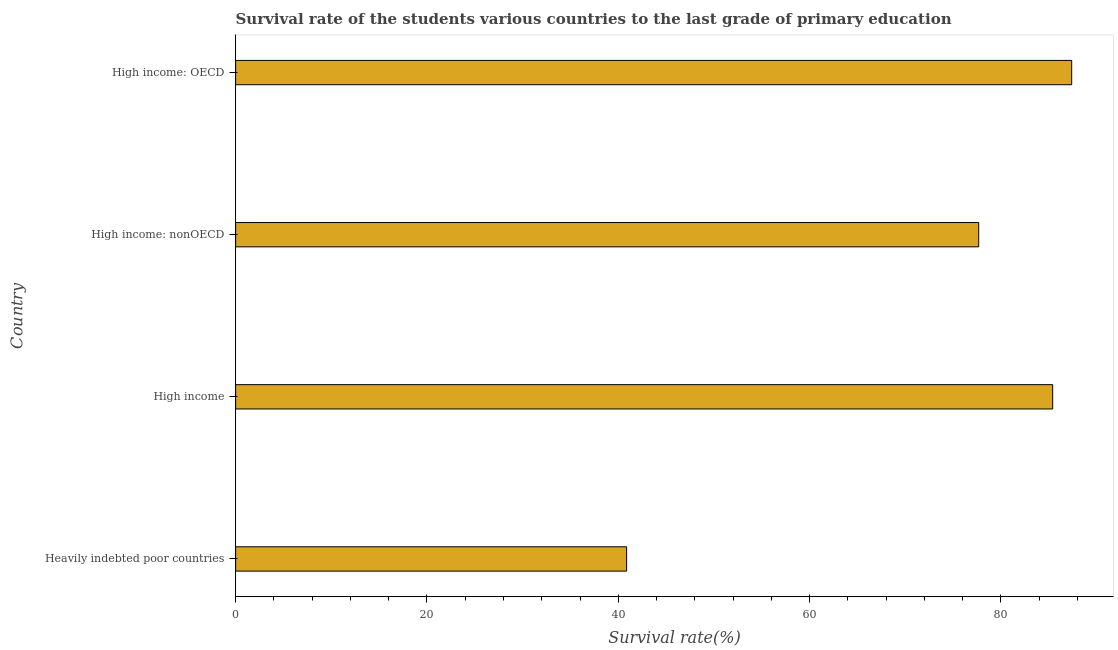What is the title of the graph?
Offer a terse response. Survival rate of the students various countries to the last grade of primary education. What is the label or title of the X-axis?
Your answer should be compact. Survival rate(%). What is the survival rate in primary education in Heavily indebted poor countries?
Ensure brevity in your answer.  40.87. Across all countries, what is the maximum survival rate in primary education?
Offer a very short reply. 87.39. Across all countries, what is the minimum survival rate in primary education?
Ensure brevity in your answer.  40.87. In which country was the survival rate in primary education maximum?
Ensure brevity in your answer.  High income: OECD. In which country was the survival rate in primary education minimum?
Provide a succinct answer. Heavily indebted poor countries. What is the sum of the survival rate in primary education?
Provide a succinct answer. 291.35. What is the difference between the survival rate in primary education in High income and High income: OECD?
Keep it short and to the point. -1.99. What is the average survival rate in primary education per country?
Ensure brevity in your answer.  72.84. What is the median survival rate in primary education?
Keep it short and to the point. 81.54. What is the ratio of the survival rate in primary education in Heavily indebted poor countries to that in High income: nonOECD?
Your answer should be compact. 0.53. What is the difference between the highest and the second highest survival rate in primary education?
Provide a short and direct response. 1.99. What is the difference between the highest and the lowest survival rate in primary education?
Provide a succinct answer. 46.52. Are all the bars in the graph horizontal?
Your answer should be very brief. Yes. What is the difference between two consecutive major ticks on the X-axis?
Provide a short and direct response. 20. Are the values on the major ticks of X-axis written in scientific E-notation?
Your response must be concise. No. What is the Survival rate(%) in Heavily indebted poor countries?
Ensure brevity in your answer.  40.87. What is the Survival rate(%) of High income?
Offer a very short reply. 85.41. What is the Survival rate(%) of High income: nonOECD?
Offer a terse response. 77.67. What is the Survival rate(%) of High income: OECD?
Your answer should be very brief. 87.39. What is the difference between the Survival rate(%) in Heavily indebted poor countries and High income?
Provide a short and direct response. -44.54. What is the difference between the Survival rate(%) in Heavily indebted poor countries and High income: nonOECD?
Your response must be concise. -36.81. What is the difference between the Survival rate(%) in Heavily indebted poor countries and High income: OECD?
Provide a short and direct response. -46.52. What is the difference between the Survival rate(%) in High income and High income: nonOECD?
Your answer should be compact. 7.73. What is the difference between the Survival rate(%) in High income and High income: OECD?
Keep it short and to the point. -1.99. What is the difference between the Survival rate(%) in High income: nonOECD and High income: OECD?
Offer a very short reply. -9.72. What is the ratio of the Survival rate(%) in Heavily indebted poor countries to that in High income?
Keep it short and to the point. 0.48. What is the ratio of the Survival rate(%) in Heavily indebted poor countries to that in High income: nonOECD?
Your answer should be compact. 0.53. What is the ratio of the Survival rate(%) in Heavily indebted poor countries to that in High income: OECD?
Provide a short and direct response. 0.47. What is the ratio of the Survival rate(%) in High income: nonOECD to that in High income: OECD?
Make the answer very short. 0.89. 